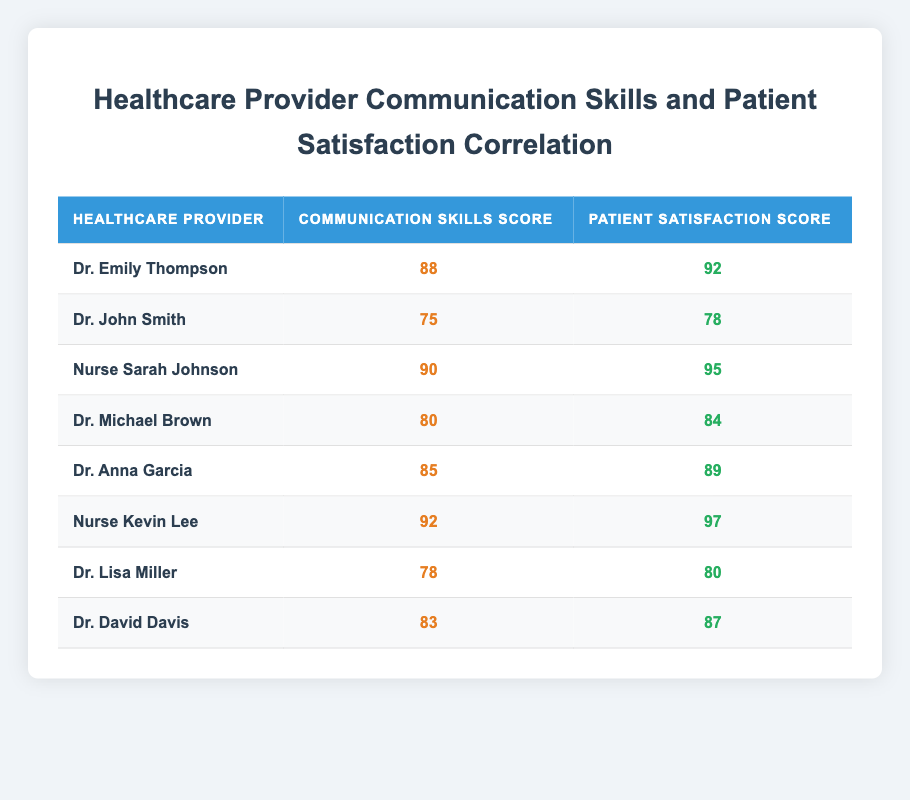What is the communication skills score of Nurse Kevin Lee? Nurse Kevin Lee's communication skills score is stated directly in the table under his name, which shows a score of 92.
Answer: 92 What is the patient satisfaction score of Dr. Anna Garcia? The patient satisfaction score for Dr. Anna Garcia can be found directly in the table next to her name, which shows a score of 89.
Answer: 89 Which healthcare provider has the highest patient satisfaction score? To determine the highest patient satisfaction score, we review the scores listed in the table. Nurse Kevin Lee has the highest score at 97.
Answer: Nurse Kevin Lee What is the average communication skills score of all healthcare providers in this table? To find the average, we add all the communication skills scores: 88 + 75 + 90 + 80 + 85 + 92 + 78 + 83 = 791. There are 8 providers, so the average is 791 / 8 = 98.875.
Answer: 98.875 Is the patient satisfaction score of Dr. John Smith greater than 75? Dr. John Smith's patient satisfaction score is listed as 78 in the table, which is indeed greater than 75.
Answer: Yes Which healthcare provider has the closest patient satisfaction score to their communication skills score? We compute the differences between each provider's communication skills and patient satisfaction scores. The smallest difference is for Dr. Michael Brown (Difference: 84 - 80 = 4).
Answer: Dr. Michael Brown How many healthcare providers have a communication skills score of 85 or higher? We list the providers with scores of 85 or higher: Dr. Emily Thompson (88), Nurse Sarah Johnson (90), Dr. Anna Garcia (85), Nurse Kevin Lee (92), and Dr. David Davis (83). This gives us a total of 5 providers.
Answer: 5 What is the difference between the highest and lowest patient satisfaction scores among the providers? The highest patient satisfaction score is 97 (Nurse Kevin Lee) and the lowest is 78 (Dr. John Smith). The difference is calculated as 97 - 78 = 19.
Answer: 19 Are there any healthcare providers with the same communication skills score? In the table, no healthcare providers have the same communication skills score, as checked against each unique score listed.
Answer: No 